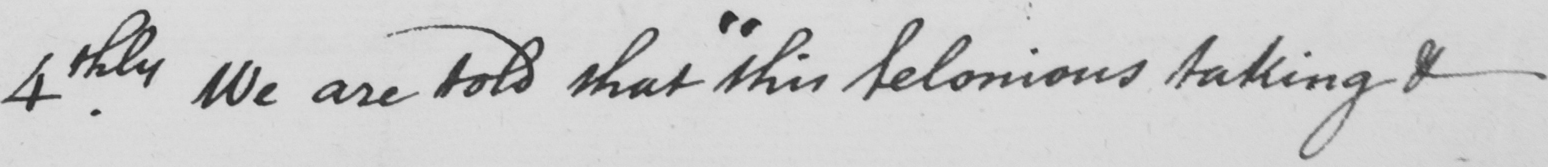Please transcribe the handwritten text in this image. 4.thly We are told that  " this felonious taking & 